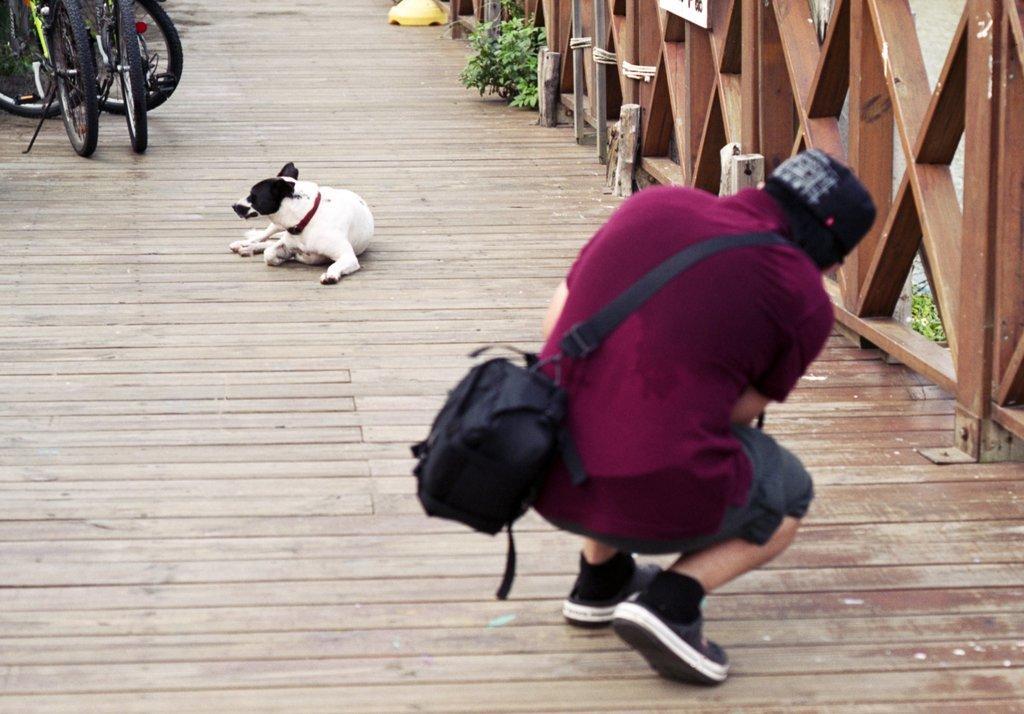Please provide a concise description of this image. In this image I can see the person with grey and pink color dress. I can see the person wearing the bag. In-front of the person I can see the dog which is in black and white color. To the left there are bicycles. To the right there is a railing and the water. I can also see the plants. The person is on the wooden surface, 